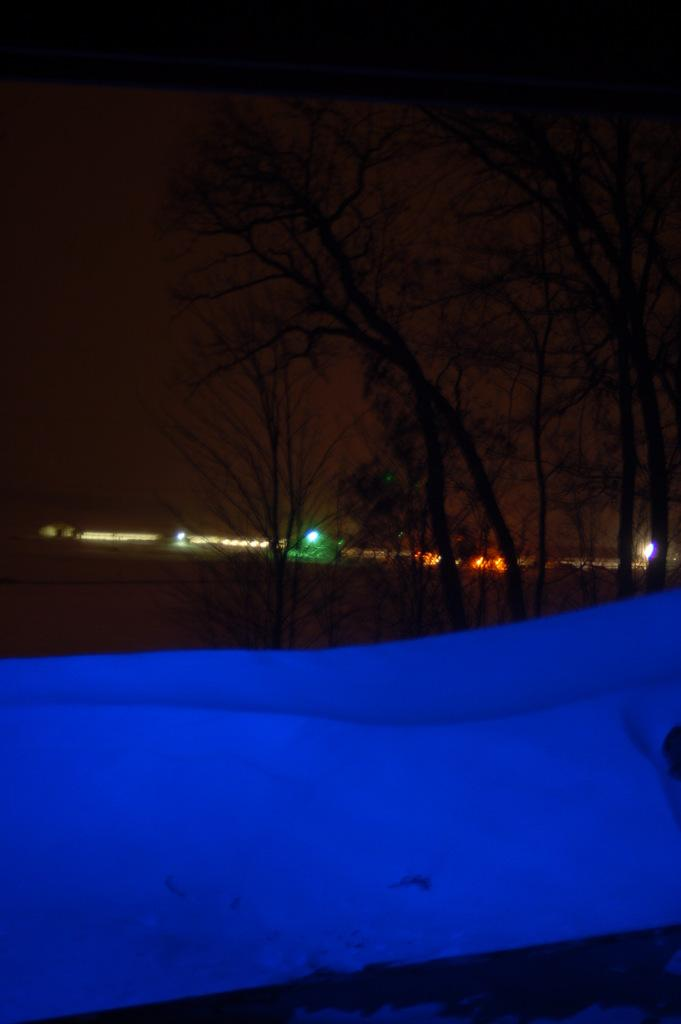What type of vegetation can be seen in the image? There are trees in the image. What can be seen in the background of the image? There are lights visible in the background of the image. What is visible in the sky in the image? Clouds are visible in the sky in the image. How many fingers can be seen pointing at the trees in the image? There are no fingers visible in the image, as it only features trees, lights, and clouds. 